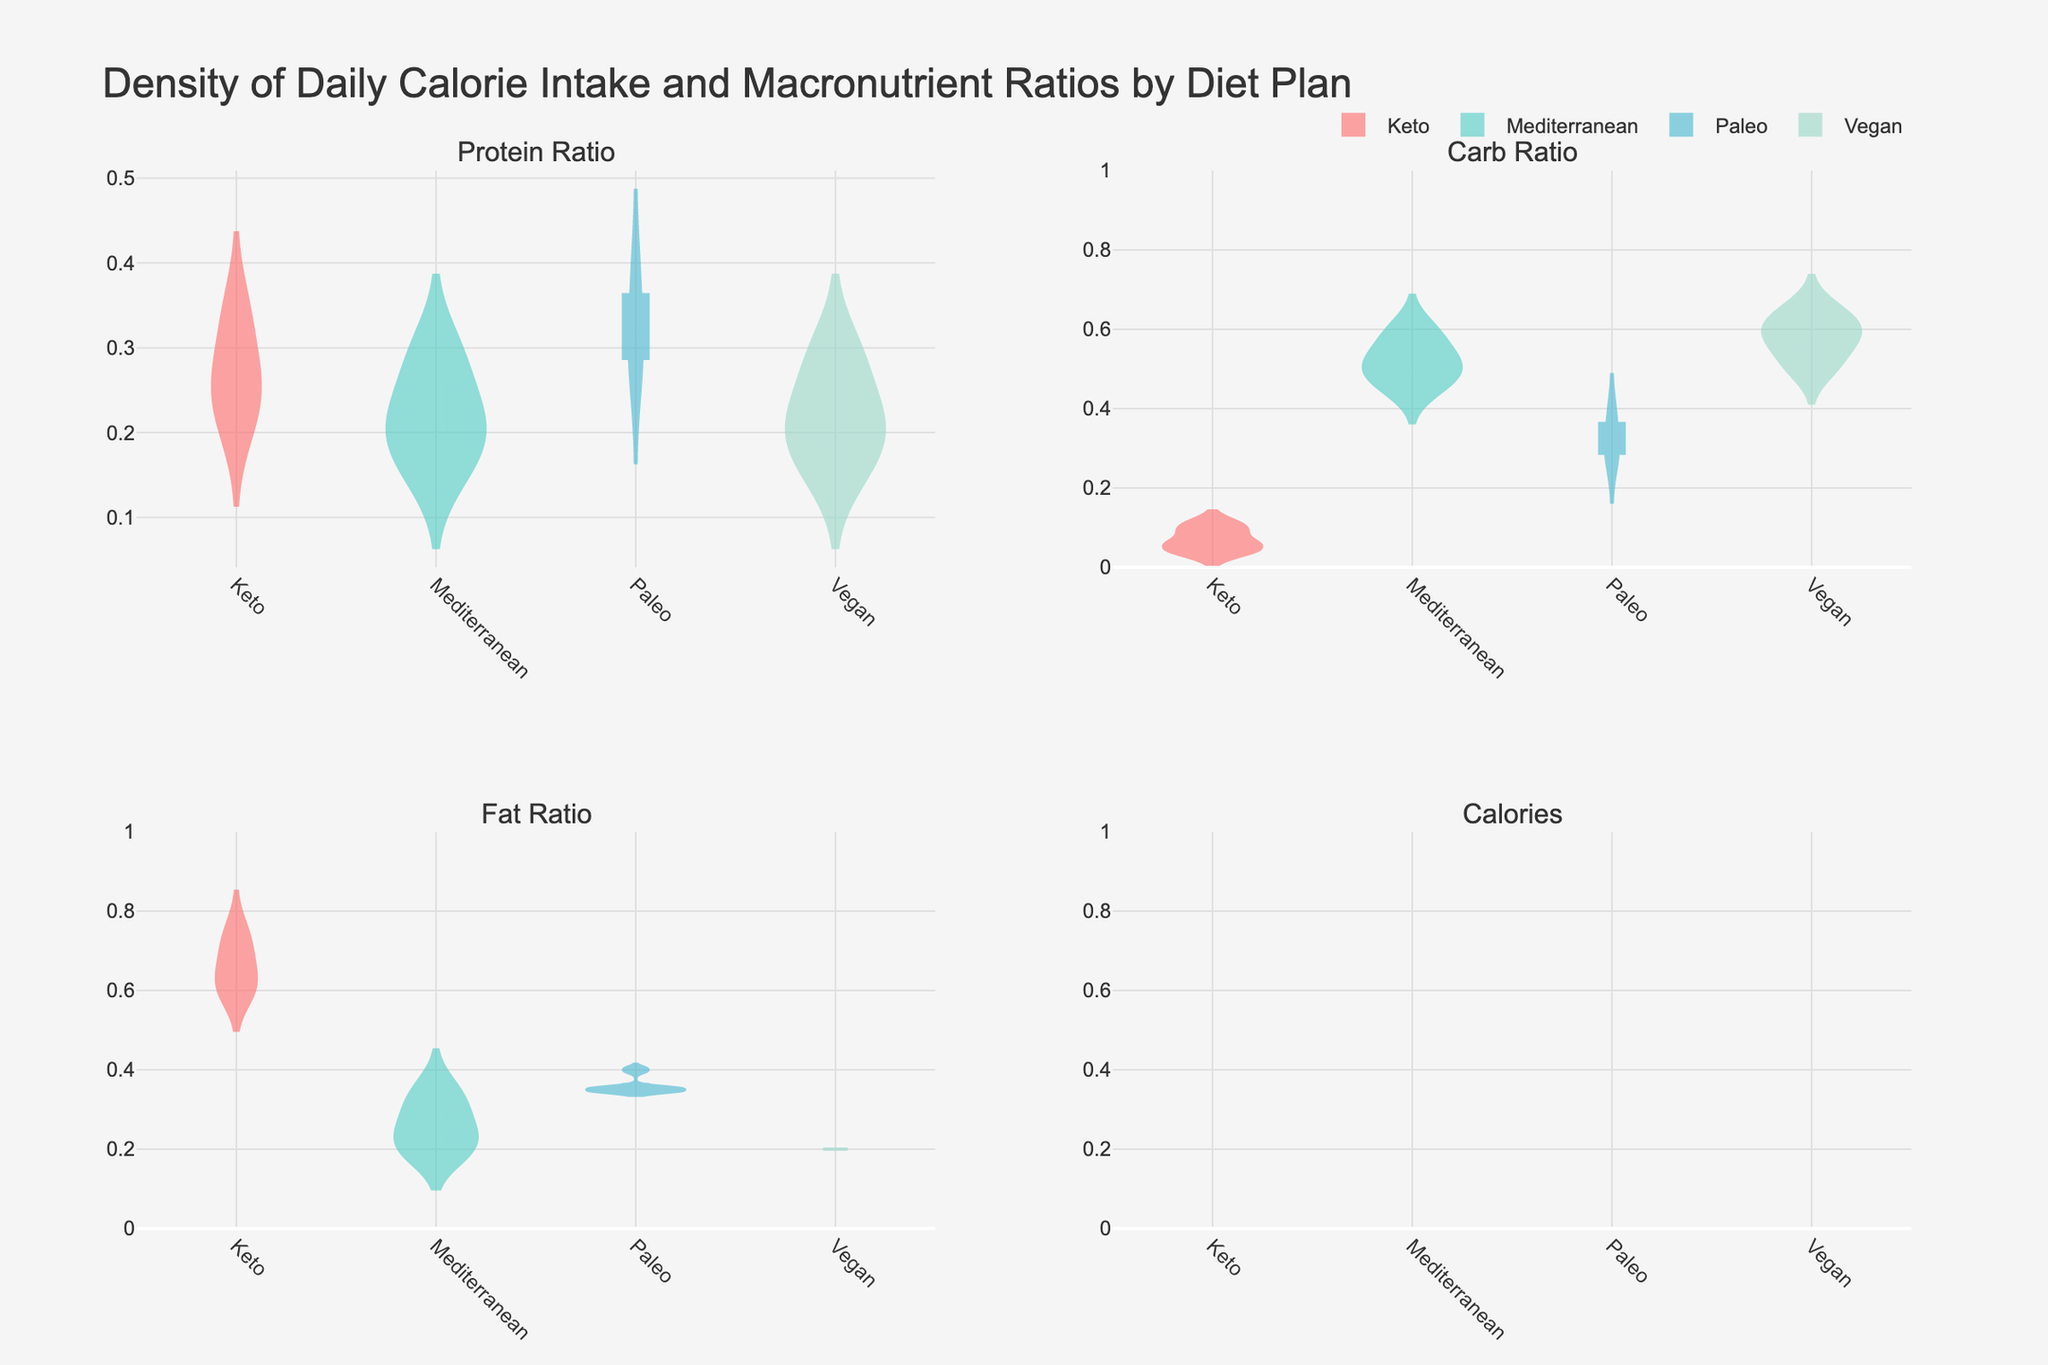What is the title of the plot? The title is located at the top of the figure, it reads: "Density of Daily Calorie Intake and Macronutrient Ratios by Diet Plan".
Answer: Density of Daily Calorie Intake and Macronutrient Ratios by Diet Plan Which diet plan has the highest mean protein ratio? By observing the violin plots in the "Protein Ratio" subplot, the Keto diet shows the highest mean line located toward the upper part of its violin plot.
Answer: Keto How do the median calorie intakes compare between the Vegan and Mediterranean diets? In the "Calories" subplot, identify the median lines within each violin plot for the Vegan and Mediterranean diets. The median calorie intake for Vegan is slightly lower than that of Mediterranean.
Answer: Vegan is lower than Mediterranean Which diet has the widest variation in carb ratios? By examining the spread of each violin plot in the "Carb Ratio" subplot, the Mediterranean diet shows the widest spread, indicating a larger variation.
Answer: Mediterranean Is there any diet plan where the fat ratio does not exceed 0.4? In the "Fat Ratio" subplot, the Vegan diet's violin plot does not extend beyond the 0.4 mark, whereas others do.
Answer: Vegan Which two diet plans have the closest mean values for calorie intake? Compare the mean lines in the "Calories" subplot for all diets. The close means between Paleo and Mediterranean are most notable, appearing almost at the same level.
Answer: Paleo and Mediterranean Looking at the "Protein Ratio" subplot, compare the ranges for Keto and Mediterranean. Keto displays a narrow protein ratio range from about 0.2 to 0.35. Mediterranean shows a wider range from about 0.15 to 0.30, indicating Mediterranean has a more varied intake.
Answer: Keto has a narrower range than Mediterranean What can you infer about the relationship between protein and carb ratios in the Vegan diet? Cross-referencing the "Protein Ratio" and "Carb Ratio" subplots for the Vegan diet, Vegan's high carb ratios (around 0.50 to 0.65) complement relatively low protein ratios (0.15 to 0.30).
Answer: Inverse relationship Is the median fat ratio higher in the Keto or Paleo diet plan? In the "Fat Ratio" subplot, observe the median lines within the Keto and Paleo violin plots. The Keto diet's median is higher compared to Paleo's median.
Answer: Keto Which diet plan shows the least variation in daily calorie intake? In the "Calories" subplot, the Vegan diet shows the least spread in its violin plot, indicating minimal variation in daily calorie intake.
Answer: Vegan 